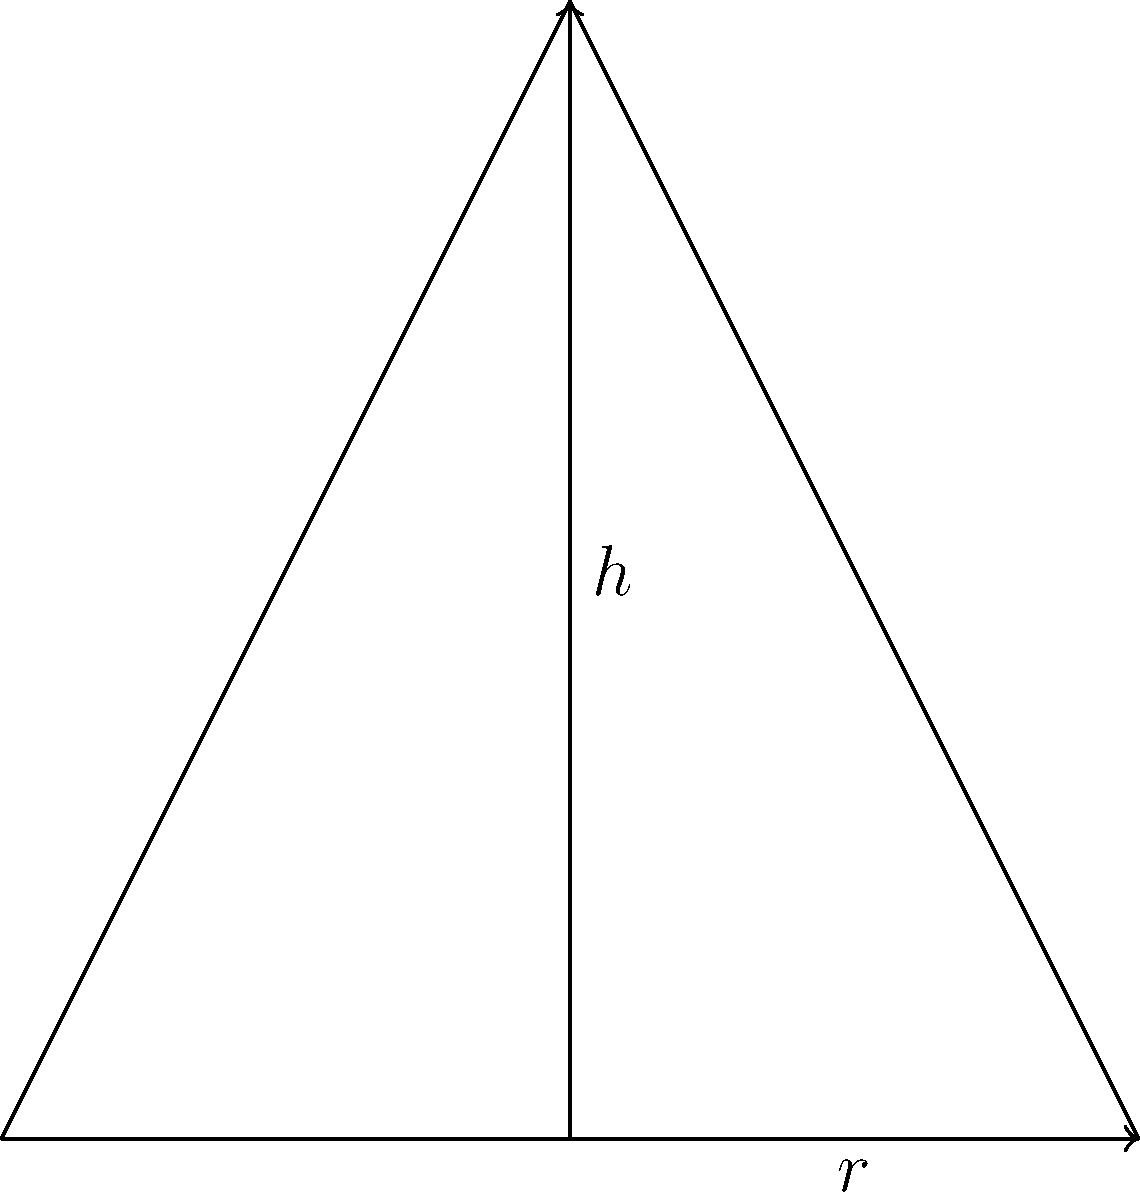A conical water tank has a radius of 3 meters and a height of 6 meters. Calculate the capacity of the tank in cubic meters, rounded to the nearest whole number. To calculate the capacity of a conical water tank, we need to use the formula for the volume of a cone:

$$V = \frac{1}{3} \pi r^2 h$$

Where:
$V$ = volume (capacity)
$r$ = radius of the base
$h$ = height of the cone

Given:
$r = 3$ meters
$h = 6$ meters

Let's substitute these values into the formula:

$$V = \frac{1}{3} \pi (3\text{ m})^2 (6\text{ m})$$

$$V = \frac{1}{3} \pi (9\text{ m}^2) (6\text{ m})$$

$$V = 18\pi\text{ m}^3$$

Now, let's calculate this value:

$$V \approx 18 \times 3.14159 \text{ m}^3$$

$$V \approx 56.55 \text{ m}^3$$

Rounding to the nearest whole number:

$$V \approx 57 \text{ m}^3$$

Therefore, the capacity of the conical water tank is approximately 57 cubic meters.
Answer: 57 cubic meters 